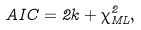<formula> <loc_0><loc_0><loc_500><loc_500>A I C = 2 k + \chi ^ { 2 } _ { M L } ,</formula> 